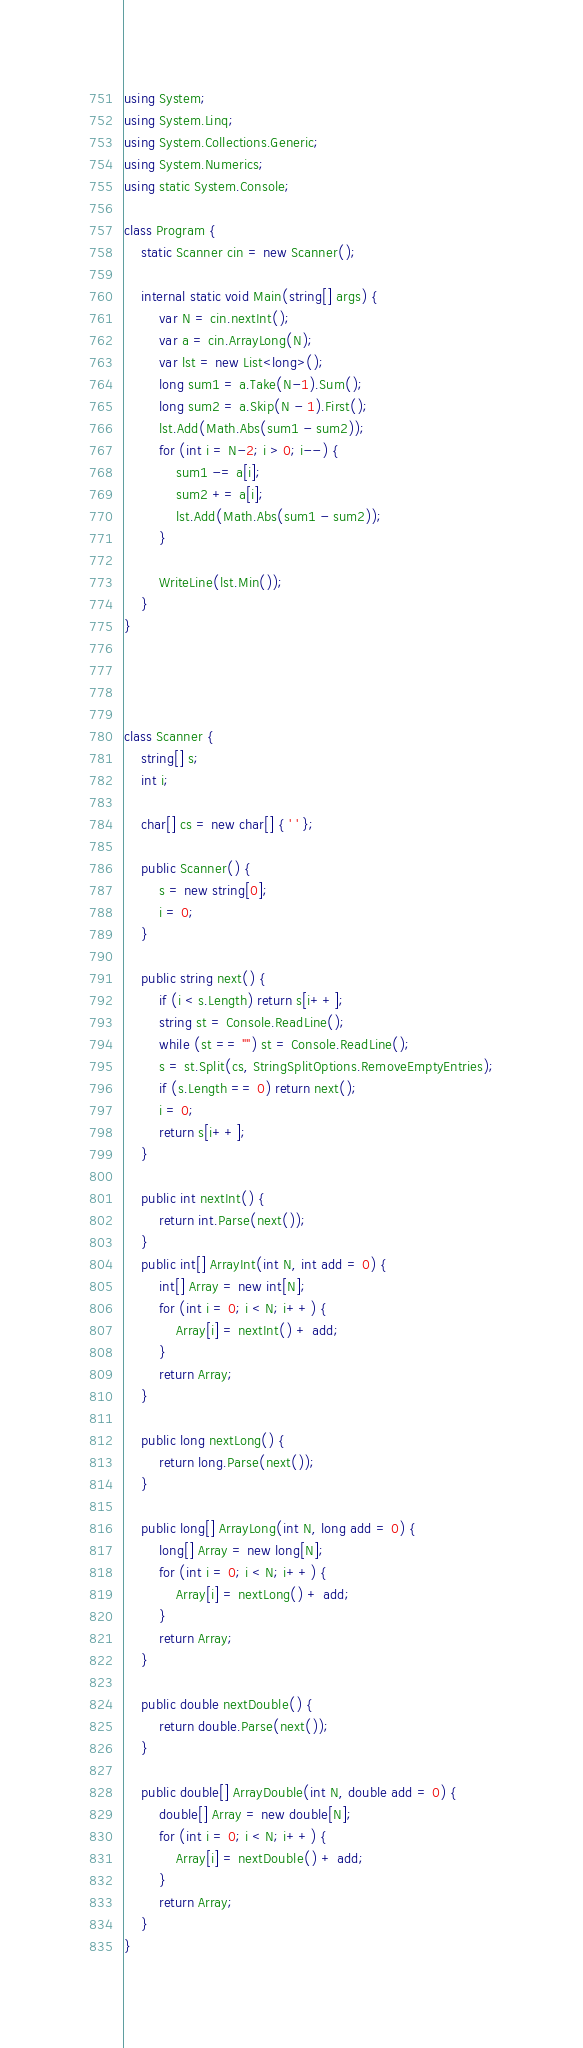<code> <loc_0><loc_0><loc_500><loc_500><_C#_>using System;
using System.Linq;
using System.Collections.Generic;
using System.Numerics;
using static System.Console;

class Program {
    static Scanner cin = new Scanner();

    internal static void Main(string[] args) {
        var N = cin.nextInt();
        var a = cin.ArrayLong(N);
        var lst = new List<long>();
        long sum1 = a.Take(N-1).Sum();
        long sum2 = a.Skip(N - 1).First();
        lst.Add(Math.Abs(sum1 - sum2));
        for (int i = N-2; i > 0; i--) {
            sum1 -= a[i];
            sum2 += a[i];
            lst.Add(Math.Abs(sum1 - sum2));
        }

        WriteLine(lst.Min());
    }
}




class Scanner {
    string[] s;
    int i;

    char[] cs = new char[] { ' ' };

    public Scanner() {
        s = new string[0];
        i = 0;
    }

    public string next() {
        if (i < s.Length) return s[i++];
        string st = Console.ReadLine();
        while (st == "") st = Console.ReadLine();
        s = st.Split(cs, StringSplitOptions.RemoveEmptyEntries);
        if (s.Length == 0) return next();
        i = 0;
        return s[i++];
    }

    public int nextInt() {
        return int.Parse(next());
    }
    public int[] ArrayInt(int N, int add = 0) {
        int[] Array = new int[N];
        for (int i = 0; i < N; i++) {
            Array[i] = nextInt() + add;
        }
        return Array;
    }

    public long nextLong() {
        return long.Parse(next());
    }

    public long[] ArrayLong(int N, long add = 0) {
        long[] Array = new long[N];
        for (int i = 0; i < N; i++) {
            Array[i] = nextLong() + add;
        }
        return Array;
    }

    public double nextDouble() {
        return double.Parse(next());
    }

    public double[] ArrayDouble(int N, double add = 0) {
        double[] Array = new double[N];
        for (int i = 0; i < N; i++) {
            Array[i] = nextDouble() + add;
        }
        return Array;
    }
}</code> 